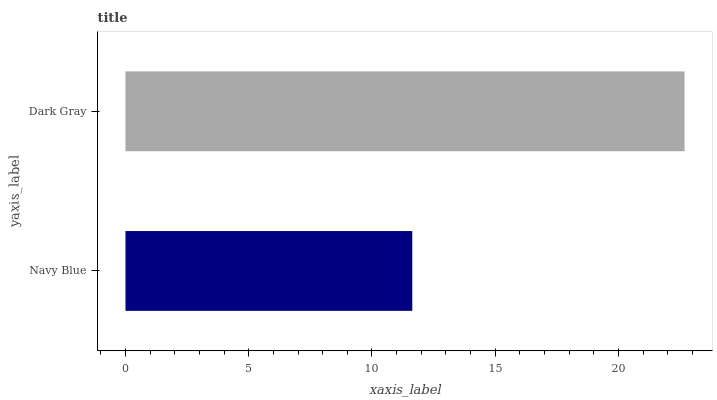Is Navy Blue the minimum?
Answer yes or no. Yes. Is Dark Gray the maximum?
Answer yes or no. Yes. Is Dark Gray the minimum?
Answer yes or no. No. Is Dark Gray greater than Navy Blue?
Answer yes or no. Yes. Is Navy Blue less than Dark Gray?
Answer yes or no. Yes. Is Navy Blue greater than Dark Gray?
Answer yes or no. No. Is Dark Gray less than Navy Blue?
Answer yes or no. No. Is Dark Gray the high median?
Answer yes or no. Yes. Is Navy Blue the low median?
Answer yes or no. Yes. Is Navy Blue the high median?
Answer yes or no. No. Is Dark Gray the low median?
Answer yes or no. No. 